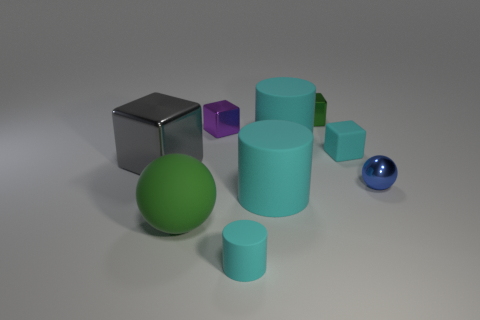Subtract all small cyan blocks. How many blocks are left? 3 Subtract all cyan cubes. How many cubes are left? 3 Subtract all brown blocks. Subtract all yellow cylinders. How many blocks are left? 4 Subtract all cylinders. How many objects are left? 6 Add 1 tiny purple cubes. How many tiny purple cubes exist? 2 Subtract 0 blue cubes. How many objects are left? 9 Subtract all green matte balls. Subtract all big objects. How many objects are left? 4 Add 4 tiny shiny cubes. How many tiny shiny cubes are left? 6 